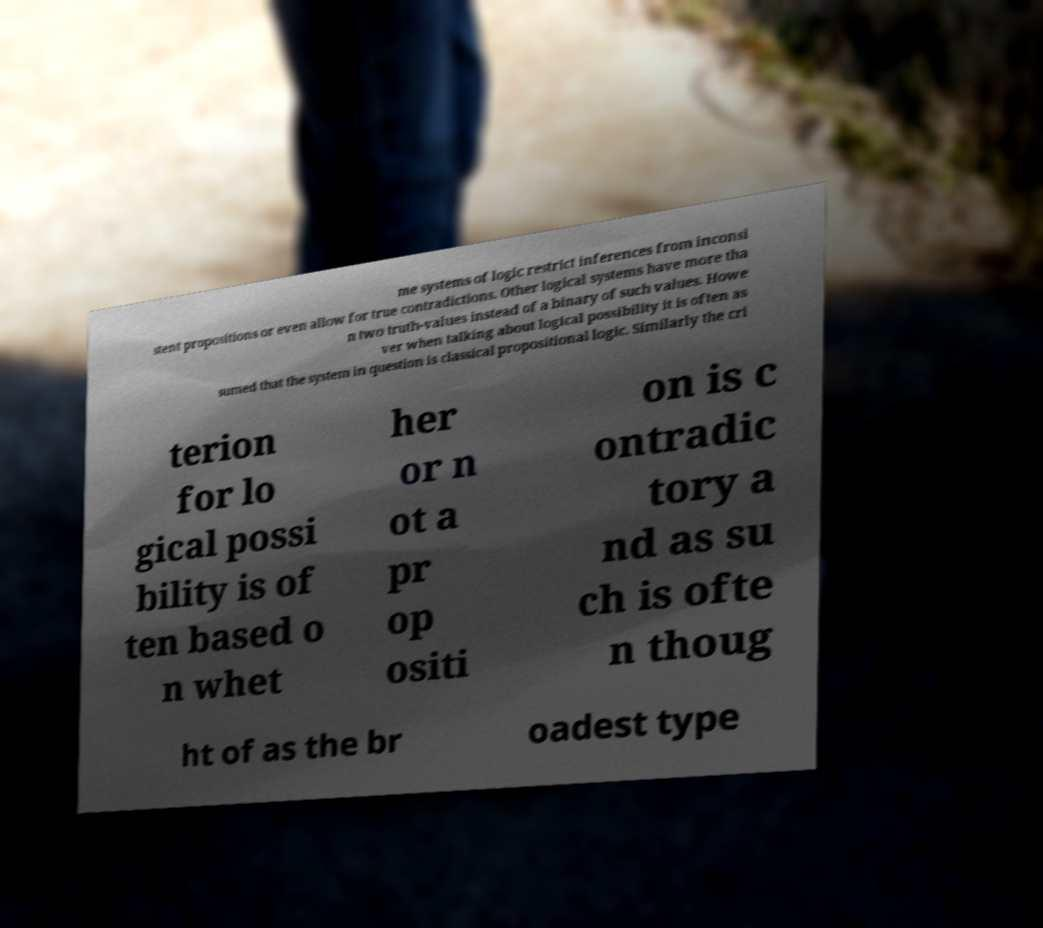Please read and relay the text visible in this image. What does it say? me systems of logic restrict inferences from inconsi stent propositions or even allow for true contradictions. Other logical systems have more tha n two truth-values instead of a binary of such values. Howe ver when talking about logical possibility it is often as sumed that the system in question is classical propositional logic. Similarly the cri terion for lo gical possi bility is of ten based o n whet her or n ot a pr op ositi on is c ontradic tory a nd as su ch is ofte n thoug ht of as the br oadest type 